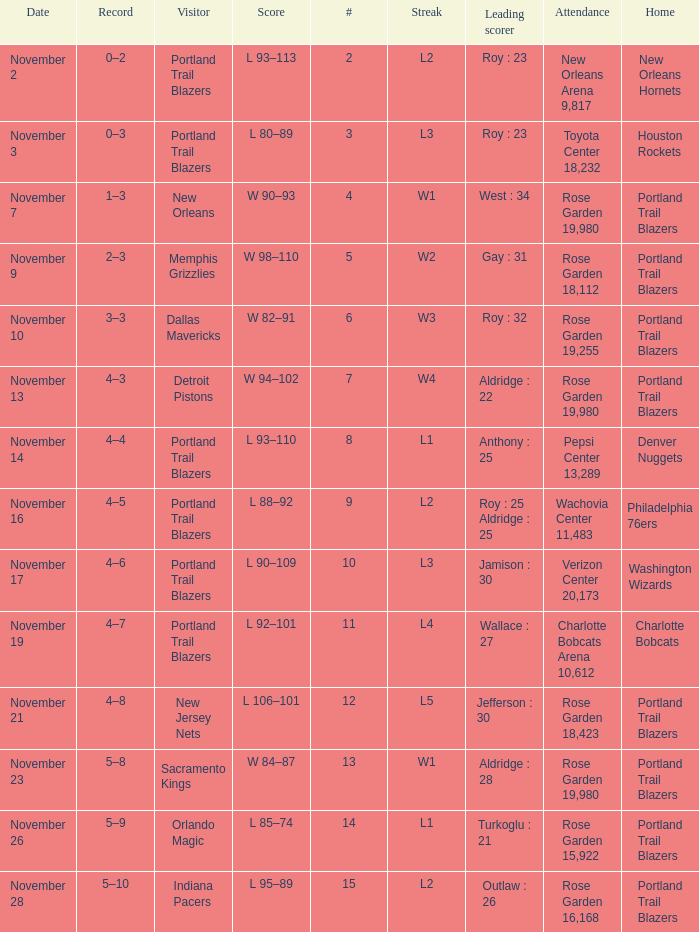 what's the attendance where score is l 92–101 Charlotte Bobcats Arena 10,612. 